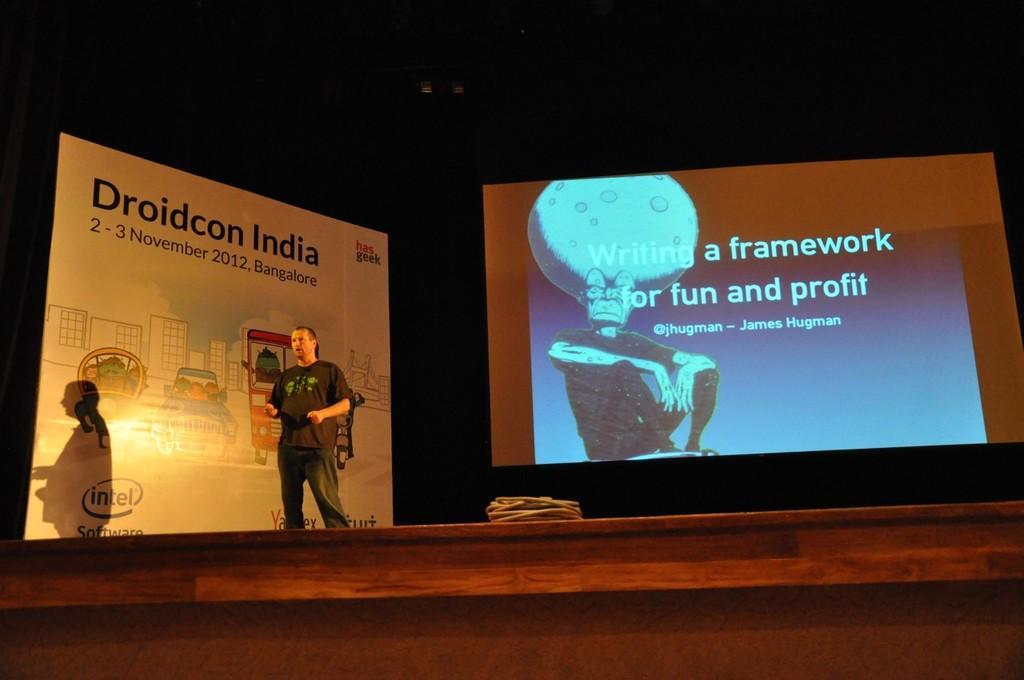Could you give a brief overview of what you see in this image? As we can see in the image there is a screen, banner, a person wearing black color t shirt and there is a bag. 